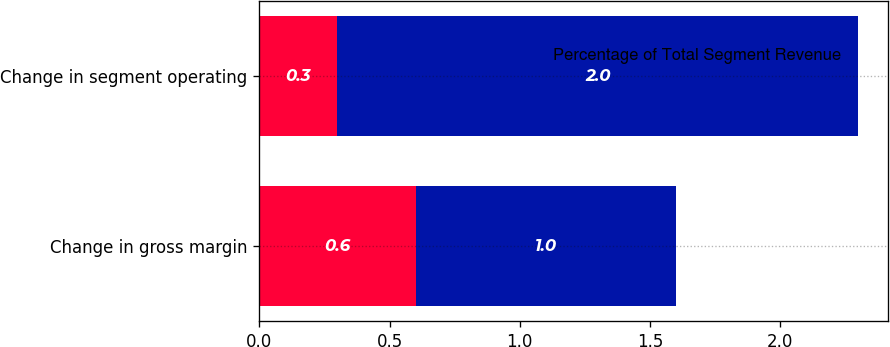Convert chart. <chart><loc_0><loc_0><loc_500><loc_500><stacked_bar_chart><ecel><fcel>Change in gross margin<fcel>Change in segment operating<nl><fcel>nan<fcel>0.6<fcel>0.3<nl><fcel>Percentage of Total Segment Revenue<fcel>1<fcel>2<nl></chart> 